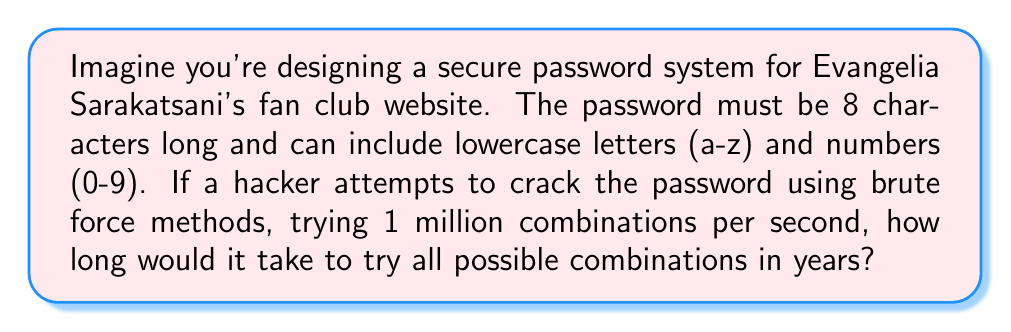Can you answer this question? Let's approach this step-by-step:

1) First, we need to calculate the total number of possible combinations:
   - We have 26 lowercase letters and 10 numbers, so 36 possible characters for each position.
   - The password is 8 characters long.
   - Total combinations = $36^8$

2) Calculate the total number of combinations:
   $36^8 = 2,821,109,907,456$

3) Now, we need to calculate how long it would take to try all these combinations:
   - The hacker can try 1,000,000 combinations per second.
   - Time in seconds = $\frac{2,821,109,907,456}{1,000,000} = 2,821,109.907456$ seconds

4) Convert seconds to years:
   - Seconds in a year = $365 \times 24 \times 60 \times 60 = 31,536,000$
   - Years = $\frac{2,821,109.907456}{31,536,000} \approx 0.0894$ years

Therefore, it would take approximately 0.0894 years or about 32.6 days to try all possible combinations.
Answer: 0.0894 years 